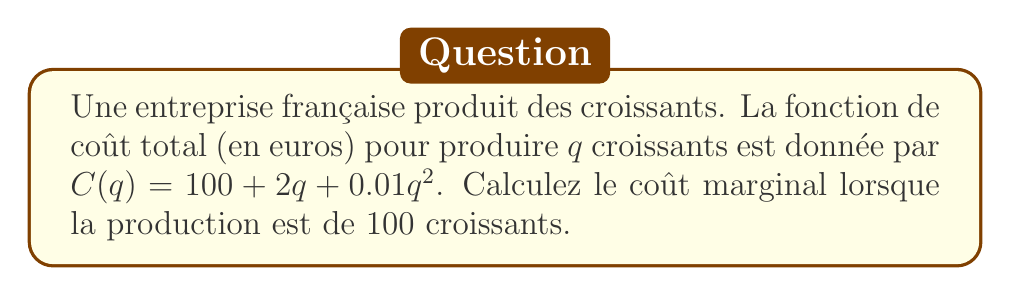Give your solution to this math problem. 1. Le coût marginal est défini comme la dérivée de la fonction de coût total par rapport à la quantité produite. Mathématiquement, cela s'écrit :

   $MC(q) = \frac{dC}{dq}$

2. Nous avons la fonction de coût total :
   
   $C(q) = 100 + 2q + 0.01q^2$

3. Pour trouver le coût marginal, nous dérivons cette fonction par rapport à $q$ :

   $\frac{dC}{dq} = 2 + 0.02q$

4. Cette expression représente le coût marginal en fonction de $q$.

5. Pour trouver le coût marginal à 100 croissants, nous substituons $q = 100$ dans l'expression du coût marginal :

   $MC(100) = 2 + 0.02(100) = 2 + 2 = 4$

6. Donc, le coût marginal lorsque la production est de 100 croissants est de 4 euros.
Answer: 4 euros 